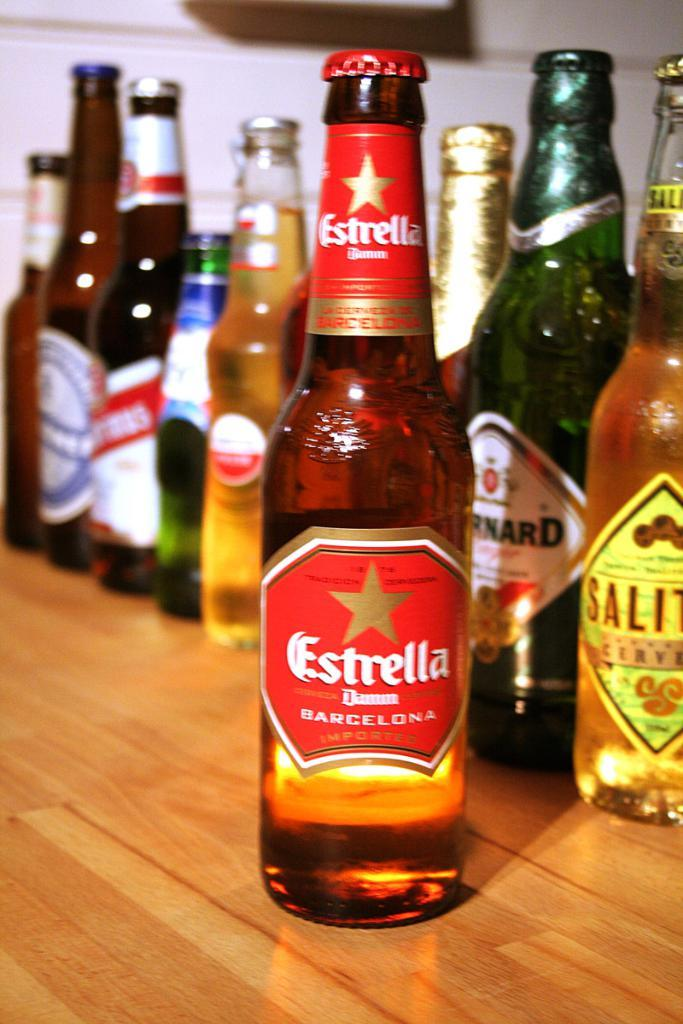Provide a one-sentence caption for the provided image. In front of many bottles of imported beer is a bottle with the label Estrella. 